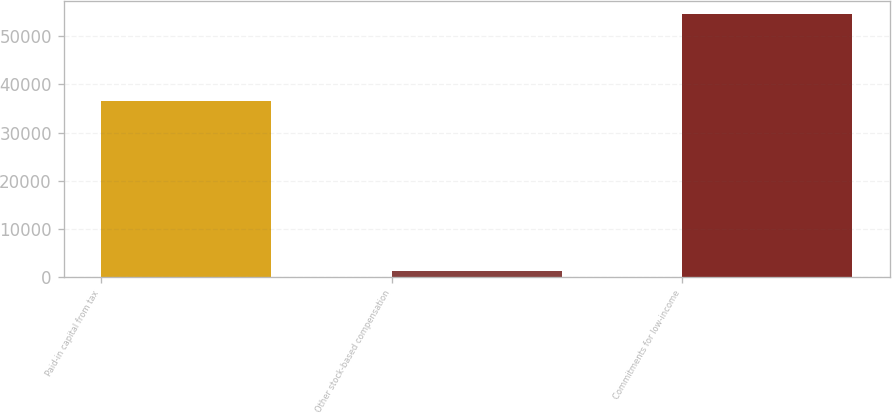Convert chart to OTSL. <chart><loc_0><loc_0><loc_500><loc_500><bar_chart><fcel>Paid-in capital from tax<fcel>Other stock-based compensation<fcel>Commitments for low-income<nl><fcel>36545<fcel>1375<fcel>54549<nl></chart> 